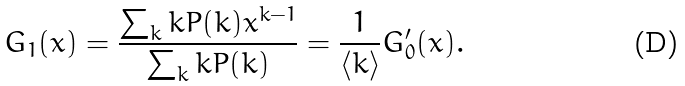<formula> <loc_0><loc_0><loc_500><loc_500>G _ { 1 } ( x ) = \frac { \sum _ { k } k P ( k ) x ^ { k - 1 } } { \sum _ { k } k P ( k ) } = \frac { 1 } { \langle k \rangle } G _ { 0 } ^ { \prime } ( x ) .</formula> 